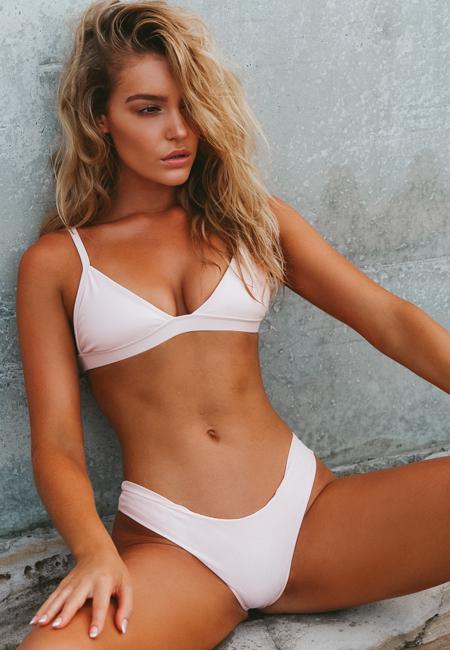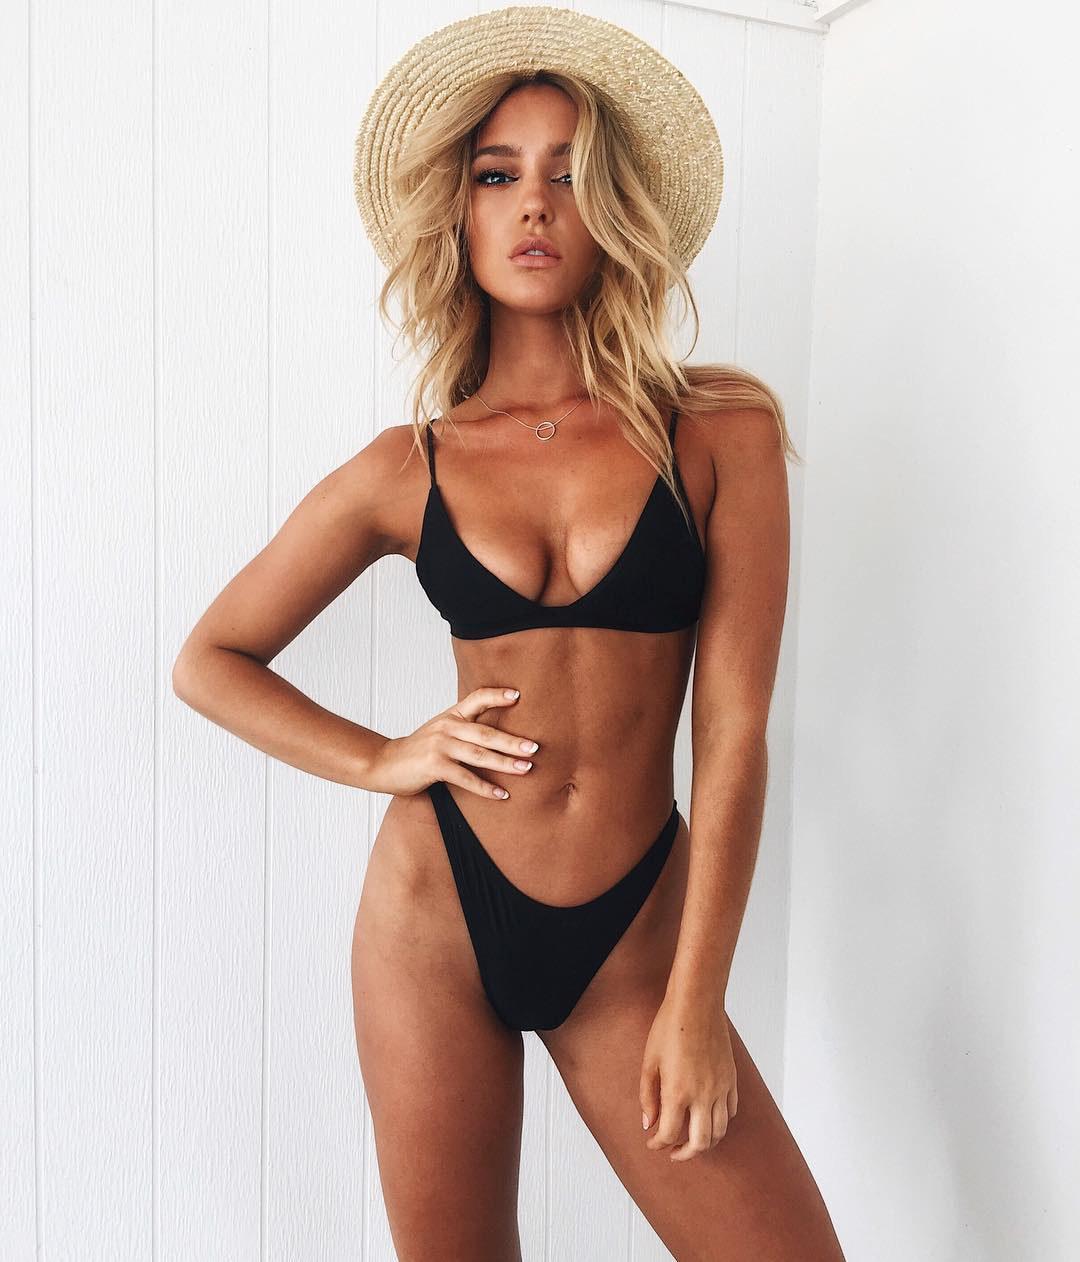The first image is the image on the left, the second image is the image on the right. For the images shown, is this caption "A woman is sitting." true? Answer yes or no. Yes. 